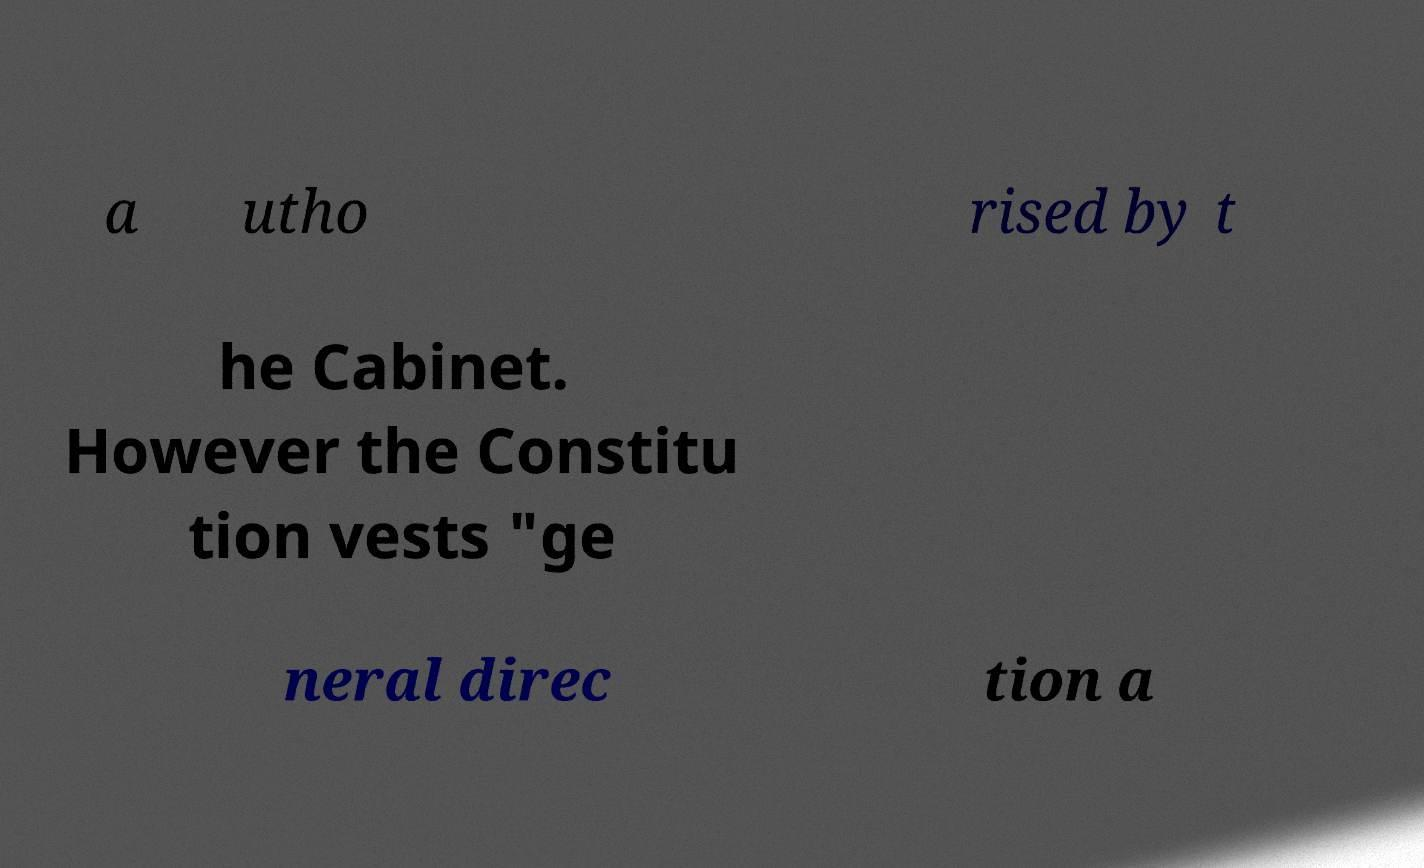Could you extract and type out the text from this image? a utho rised by t he Cabinet. However the Constitu tion vests "ge neral direc tion a 